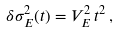<formula> <loc_0><loc_0><loc_500><loc_500>\delta \sigma _ { E } ^ { 2 } ( t ) = V _ { E } ^ { 2 } \, t ^ { 2 } \, ,</formula> 